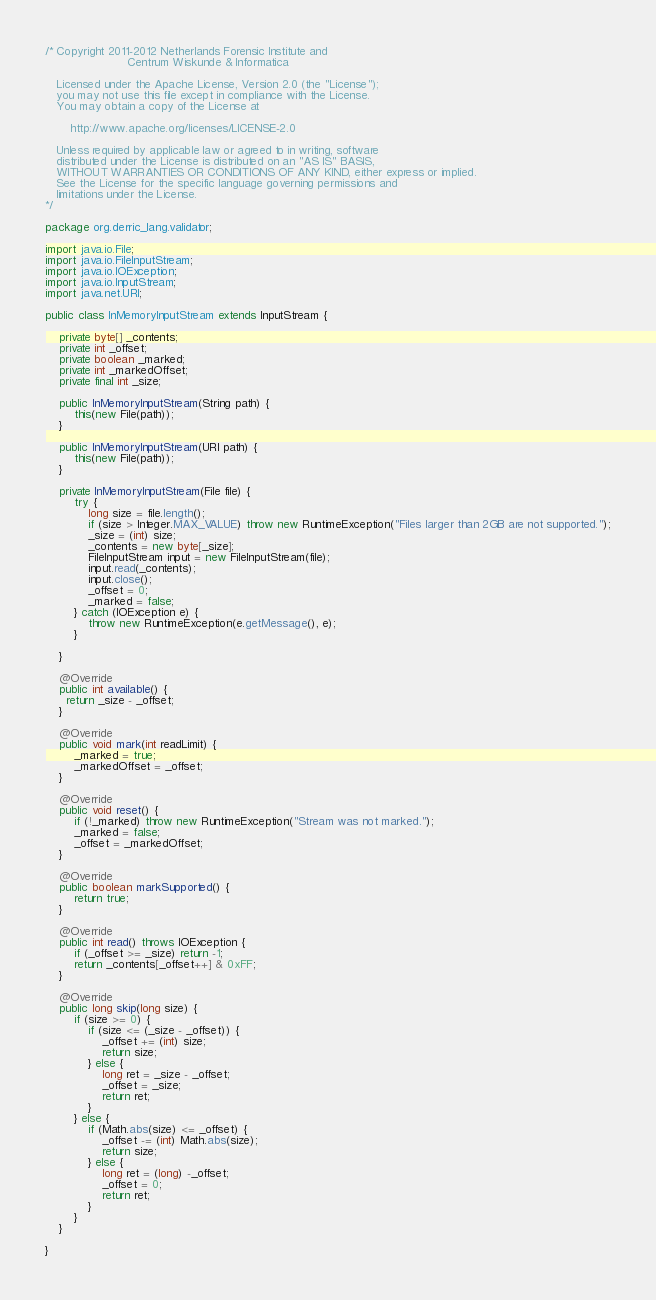<code> <loc_0><loc_0><loc_500><loc_500><_Java_>/* Copyright 2011-2012 Netherlands Forensic Institute and
                       Centrum Wiskunde & Informatica

   Licensed under the Apache License, Version 2.0 (the "License");
   you may not use this file except in compliance with the License.
   You may obtain a copy of the License at

       http://www.apache.org/licenses/LICENSE-2.0

   Unless required by applicable law or agreed to in writing, software
   distributed under the License is distributed on an "AS IS" BASIS,
   WITHOUT WARRANTIES OR CONDITIONS OF ANY KIND, either express or implied.
   See the License for the specific language governing permissions and
   limitations under the License.
*/

package org.derric_lang.validator;

import java.io.File;
import java.io.FileInputStream;
import java.io.IOException;
import java.io.InputStream;
import java.net.URI;

public class InMemoryInputStream extends InputStream {

	private byte[] _contents;
	private int _offset;
	private boolean _marked;
	private int _markedOffset;
	private final int _size;

	public InMemoryInputStream(String path) {
		this(new File(path));
	}
	
	public InMemoryInputStream(URI path) {
		this(new File(path));
	}
	
	private InMemoryInputStream(File file) {
		try {
			long size = file.length();
			if (size > Integer.MAX_VALUE) throw new RuntimeException("Files larger than 2GB are not supported.");
			_size = (int) size;
			_contents = new byte[_size];
			FileInputStream input = new FileInputStream(file);
			input.read(_contents);
			input.close();
			_offset = 0;
			_marked = false;
		} catch (IOException e) {
			throw new RuntimeException(e.getMessage(), e);
		}
	
	}
	
	@Override
	public int available() {
	  return _size - _offset;
	}

	@Override
	public void mark(int readLimit) {
		_marked = true;
		_markedOffset = _offset;
	}

	@Override
	public void reset() {
		if (!_marked) throw new RuntimeException("Stream was not marked.");
		_marked = false;
		_offset = _markedOffset;
	}

	@Override
	public boolean markSupported() {
		return true;
	}

	@Override
	public int read() throws IOException {
		if (_offset >= _size) return -1;
		return _contents[_offset++] & 0xFF;
	}

	@Override
	public long skip(long size) {
		if (size >= 0) {
			if (size <= (_size - _offset)) {
				_offset += (int) size;
				return size;
			} else {
				long ret = _size - _offset;
				_offset = _size;
				return ret;
			}
		} else {
			if (Math.abs(size) <= _offset) {
				_offset -= (int) Math.abs(size);
				return size;
			} else {
				long ret = (long) -_offset;
				_offset = 0;
				return ret;
			}
		}
	}

}
</code> 